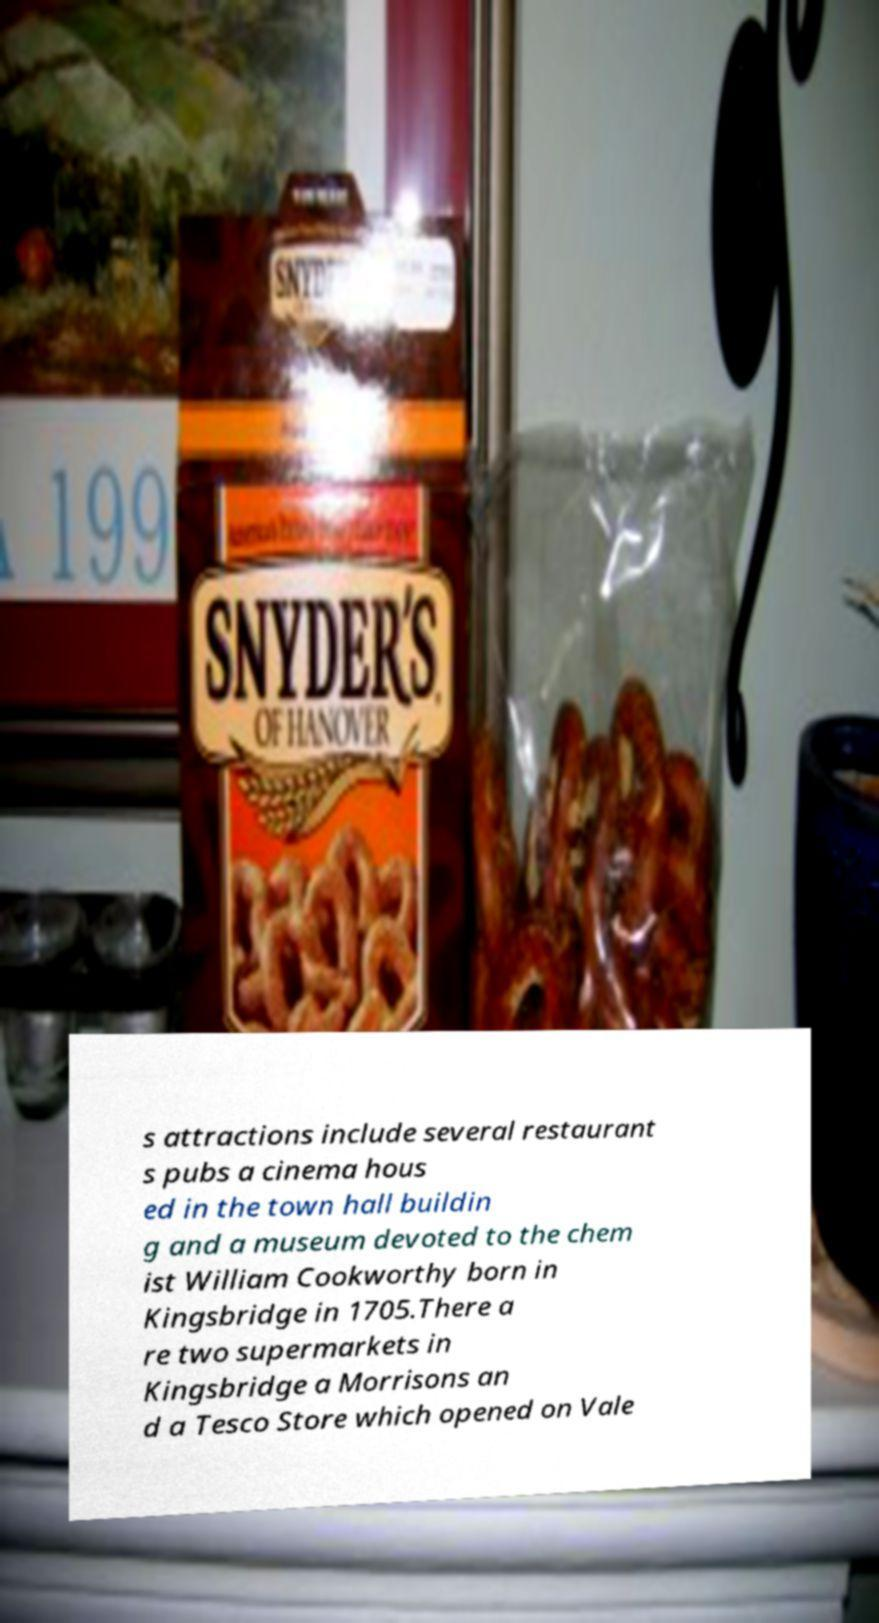There's text embedded in this image that I need extracted. Can you transcribe it verbatim? s attractions include several restaurant s pubs a cinema hous ed in the town hall buildin g and a museum devoted to the chem ist William Cookworthy born in Kingsbridge in 1705.There a re two supermarkets in Kingsbridge a Morrisons an d a Tesco Store which opened on Vale 